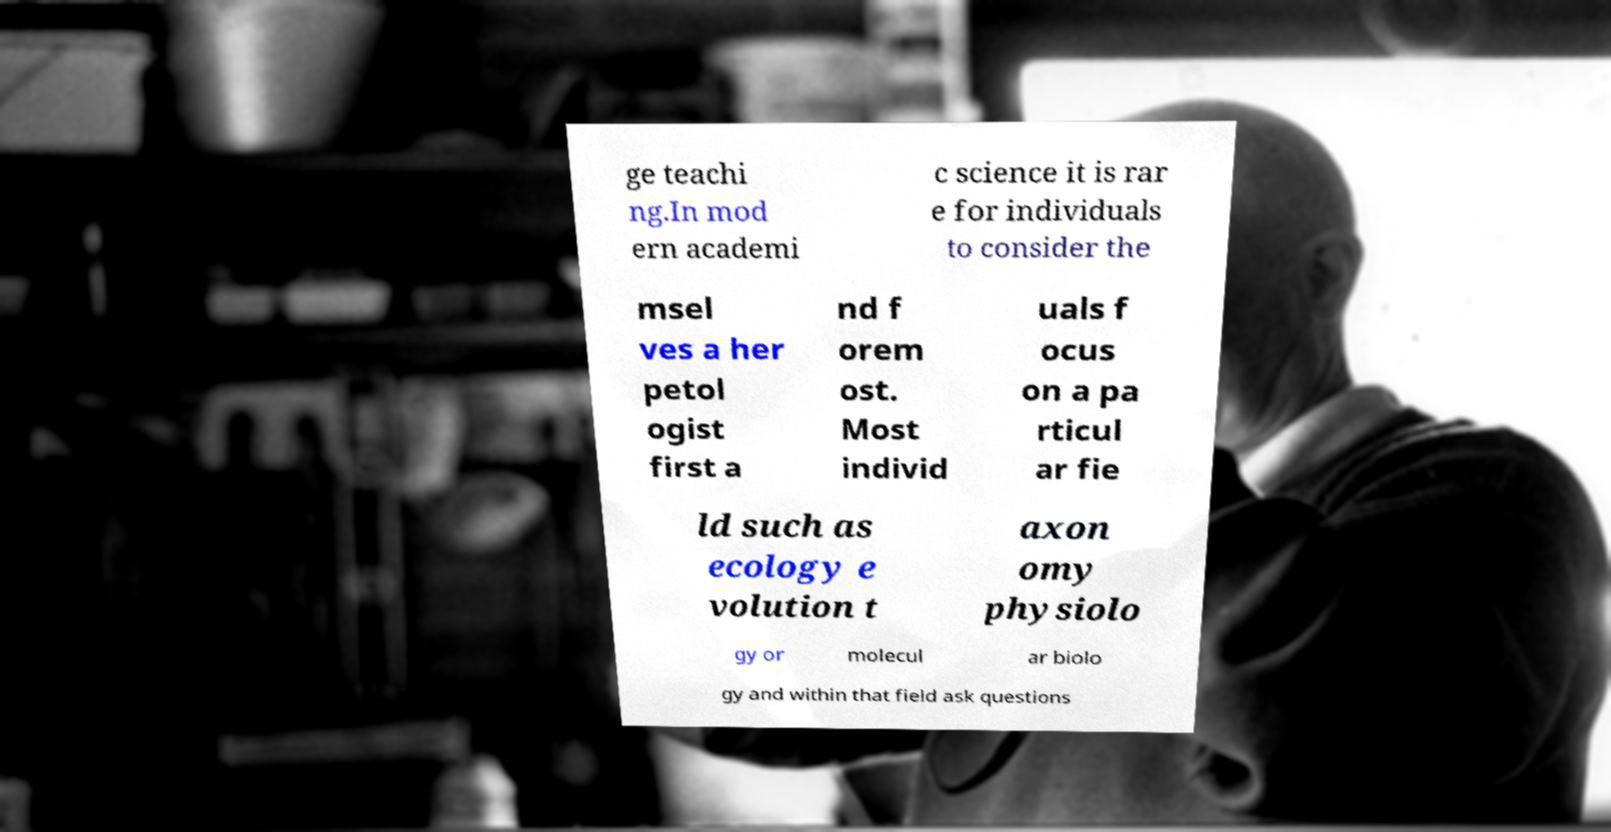I need the written content from this picture converted into text. Can you do that? ge teachi ng.In mod ern academi c science it is rar e for individuals to consider the msel ves a her petol ogist first a nd f orem ost. Most individ uals f ocus on a pa rticul ar fie ld such as ecology e volution t axon omy physiolo gy or molecul ar biolo gy and within that field ask questions 